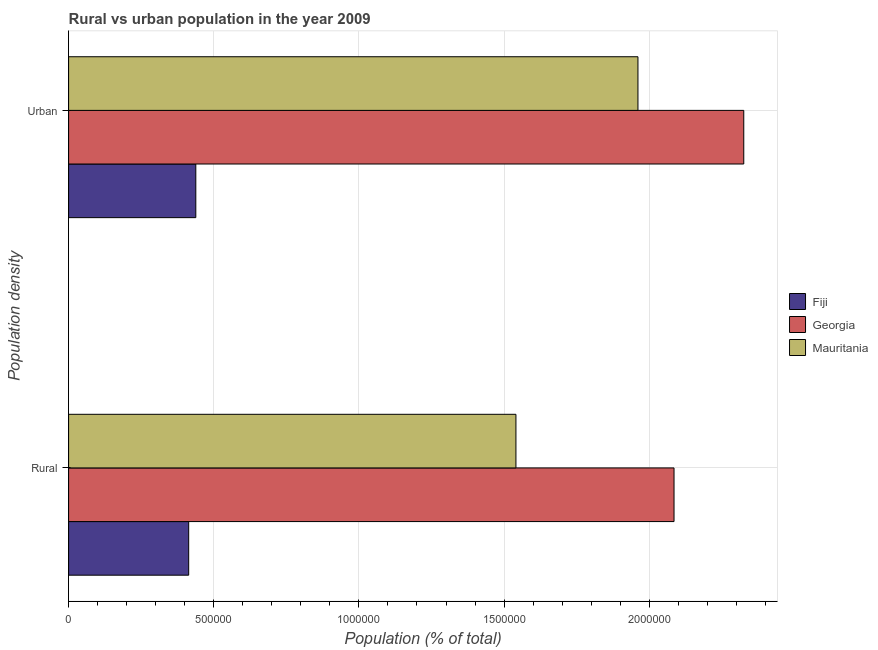How many different coloured bars are there?
Your answer should be very brief. 3. Are the number of bars on each tick of the Y-axis equal?
Your answer should be compact. Yes. How many bars are there on the 1st tick from the bottom?
Provide a succinct answer. 3. What is the label of the 2nd group of bars from the top?
Provide a succinct answer. Rural. What is the urban population density in Fiji?
Your response must be concise. 4.38e+05. Across all countries, what is the maximum rural population density?
Your answer should be very brief. 2.09e+06. Across all countries, what is the minimum rural population density?
Your answer should be very brief. 4.14e+05. In which country was the rural population density maximum?
Your answer should be very brief. Georgia. In which country was the rural population density minimum?
Keep it short and to the point. Fiji. What is the total rural population density in the graph?
Your response must be concise. 4.04e+06. What is the difference between the rural population density in Georgia and that in Fiji?
Offer a very short reply. 1.67e+06. What is the difference between the rural population density in Georgia and the urban population density in Mauritania?
Keep it short and to the point. 1.24e+05. What is the average urban population density per country?
Make the answer very short. 1.57e+06. What is the difference between the urban population density and rural population density in Mauritania?
Give a very brief answer. 4.20e+05. What is the ratio of the rural population density in Fiji to that in Georgia?
Provide a succinct answer. 0.2. Is the rural population density in Mauritania less than that in Georgia?
Provide a succinct answer. Yes. In how many countries, is the urban population density greater than the average urban population density taken over all countries?
Your answer should be very brief. 2. What does the 3rd bar from the top in Rural represents?
Keep it short and to the point. Fiji. What does the 3rd bar from the bottom in Urban represents?
Give a very brief answer. Mauritania. How many bars are there?
Make the answer very short. 6. Are all the bars in the graph horizontal?
Your answer should be very brief. Yes. How many countries are there in the graph?
Your response must be concise. 3. What is the difference between two consecutive major ticks on the X-axis?
Keep it short and to the point. 5.00e+05. Are the values on the major ticks of X-axis written in scientific E-notation?
Keep it short and to the point. No. Does the graph contain any zero values?
Keep it short and to the point. No. How many legend labels are there?
Ensure brevity in your answer.  3. How are the legend labels stacked?
Offer a terse response. Vertical. What is the title of the graph?
Make the answer very short. Rural vs urban population in the year 2009. What is the label or title of the X-axis?
Offer a very short reply. Population (% of total). What is the label or title of the Y-axis?
Your answer should be compact. Population density. What is the Population (% of total) in Fiji in Rural?
Offer a very short reply. 4.14e+05. What is the Population (% of total) in Georgia in Rural?
Offer a very short reply. 2.09e+06. What is the Population (% of total) of Mauritania in Rural?
Make the answer very short. 1.54e+06. What is the Population (% of total) in Fiji in Urban?
Ensure brevity in your answer.  4.38e+05. What is the Population (% of total) in Georgia in Urban?
Your answer should be very brief. 2.33e+06. What is the Population (% of total) in Mauritania in Urban?
Provide a short and direct response. 1.96e+06. Across all Population density, what is the maximum Population (% of total) of Fiji?
Provide a succinct answer. 4.38e+05. Across all Population density, what is the maximum Population (% of total) of Georgia?
Your response must be concise. 2.33e+06. Across all Population density, what is the maximum Population (% of total) of Mauritania?
Provide a short and direct response. 1.96e+06. Across all Population density, what is the minimum Population (% of total) of Fiji?
Your response must be concise. 4.14e+05. Across all Population density, what is the minimum Population (% of total) of Georgia?
Offer a very short reply. 2.09e+06. Across all Population density, what is the minimum Population (% of total) of Mauritania?
Your answer should be compact. 1.54e+06. What is the total Population (% of total) in Fiji in the graph?
Provide a succinct answer. 8.52e+05. What is the total Population (% of total) in Georgia in the graph?
Provide a succinct answer. 4.41e+06. What is the total Population (% of total) in Mauritania in the graph?
Your response must be concise. 3.50e+06. What is the difference between the Population (% of total) of Fiji in Rural and that in Urban?
Offer a terse response. -2.45e+04. What is the difference between the Population (% of total) of Georgia in Rural and that in Urban?
Offer a terse response. -2.40e+05. What is the difference between the Population (% of total) of Mauritania in Rural and that in Urban?
Provide a short and direct response. -4.20e+05. What is the difference between the Population (% of total) in Fiji in Rural and the Population (% of total) in Georgia in Urban?
Your answer should be compact. -1.91e+06. What is the difference between the Population (% of total) of Fiji in Rural and the Population (% of total) of Mauritania in Urban?
Your response must be concise. -1.55e+06. What is the difference between the Population (% of total) in Georgia in Rural and the Population (% of total) in Mauritania in Urban?
Keep it short and to the point. 1.24e+05. What is the average Population (% of total) in Fiji per Population density?
Your answer should be compact. 4.26e+05. What is the average Population (% of total) of Georgia per Population density?
Provide a succinct answer. 2.21e+06. What is the average Population (% of total) in Mauritania per Population density?
Offer a very short reply. 1.75e+06. What is the difference between the Population (% of total) of Fiji and Population (% of total) of Georgia in Rural?
Make the answer very short. -1.67e+06. What is the difference between the Population (% of total) in Fiji and Population (% of total) in Mauritania in Rural?
Provide a short and direct response. -1.13e+06. What is the difference between the Population (% of total) in Georgia and Population (% of total) in Mauritania in Rural?
Make the answer very short. 5.44e+05. What is the difference between the Population (% of total) in Fiji and Population (% of total) in Georgia in Urban?
Offer a terse response. -1.89e+06. What is the difference between the Population (% of total) of Fiji and Population (% of total) of Mauritania in Urban?
Keep it short and to the point. -1.52e+06. What is the difference between the Population (% of total) of Georgia and Population (% of total) of Mauritania in Urban?
Ensure brevity in your answer.  3.64e+05. What is the ratio of the Population (% of total) of Fiji in Rural to that in Urban?
Offer a very short reply. 0.94. What is the ratio of the Population (% of total) of Georgia in Rural to that in Urban?
Give a very brief answer. 0.9. What is the ratio of the Population (% of total) in Mauritania in Rural to that in Urban?
Give a very brief answer. 0.79. What is the difference between the highest and the second highest Population (% of total) of Fiji?
Keep it short and to the point. 2.45e+04. What is the difference between the highest and the second highest Population (% of total) in Georgia?
Your answer should be compact. 2.40e+05. What is the difference between the highest and the second highest Population (% of total) of Mauritania?
Your answer should be compact. 4.20e+05. What is the difference between the highest and the lowest Population (% of total) of Fiji?
Provide a short and direct response. 2.45e+04. What is the difference between the highest and the lowest Population (% of total) in Georgia?
Provide a short and direct response. 2.40e+05. What is the difference between the highest and the lowest Population (% of total) in Mauritania?
Keep it short and to the point. 4.20e+05. 